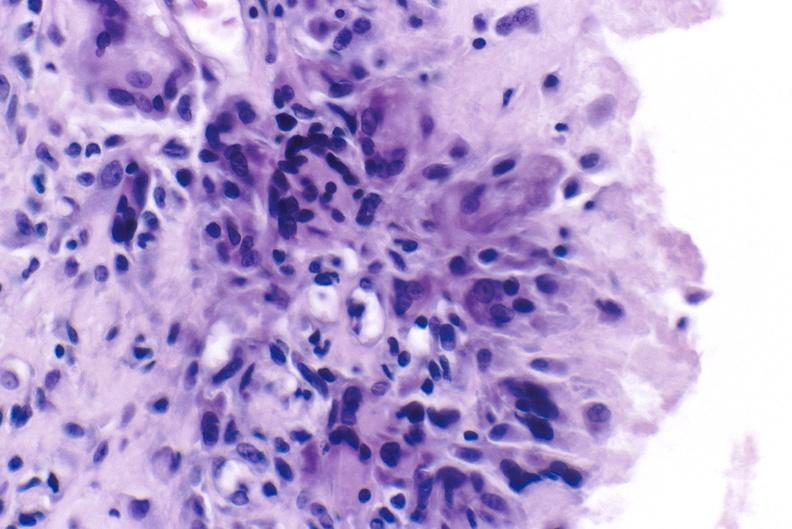s joints present?
Answer the question using a single word or phrase. Yes 